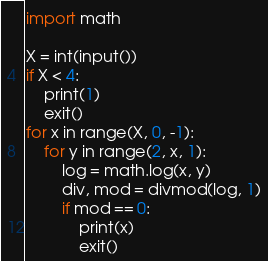Convert code to text. <code><loc_0><loc_0><loc_500><loc_500><_Python_>import math

X = int(input())
if X < 4:
    print(1)
    exit()
for x in range(X, 0, -1):
    for y in range(2, x, 1):
        log = math.log(x, y)
        div, mod = divmod(log, 1)
        if mod == 0:
            print(x)
            exit()
</code> 